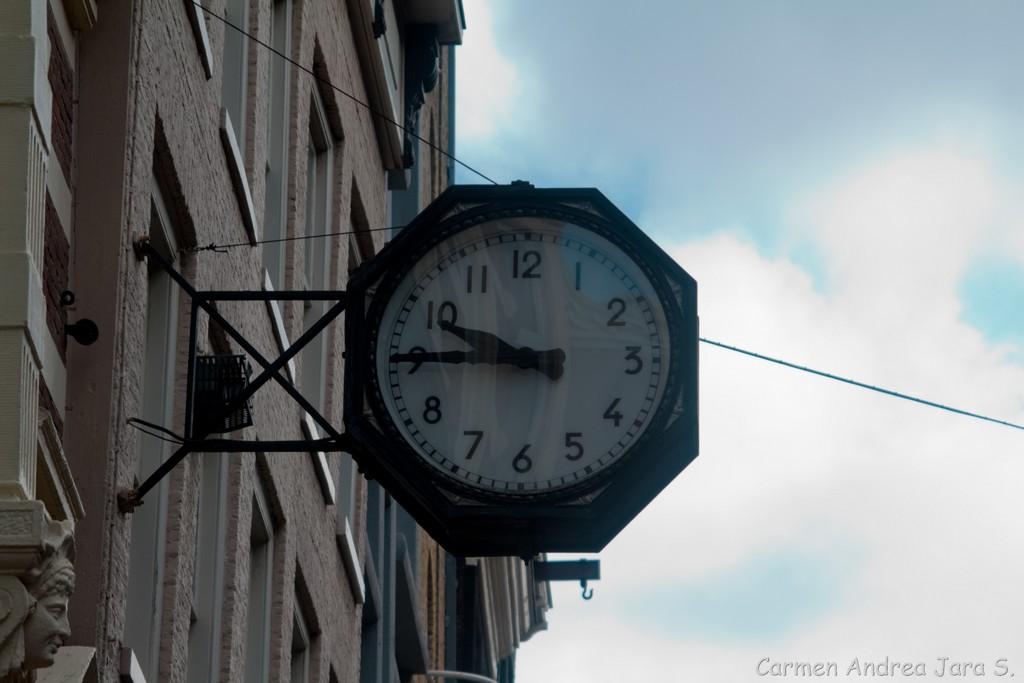What time is presented on the clock?
Keep it short and to the point. 9:45. 